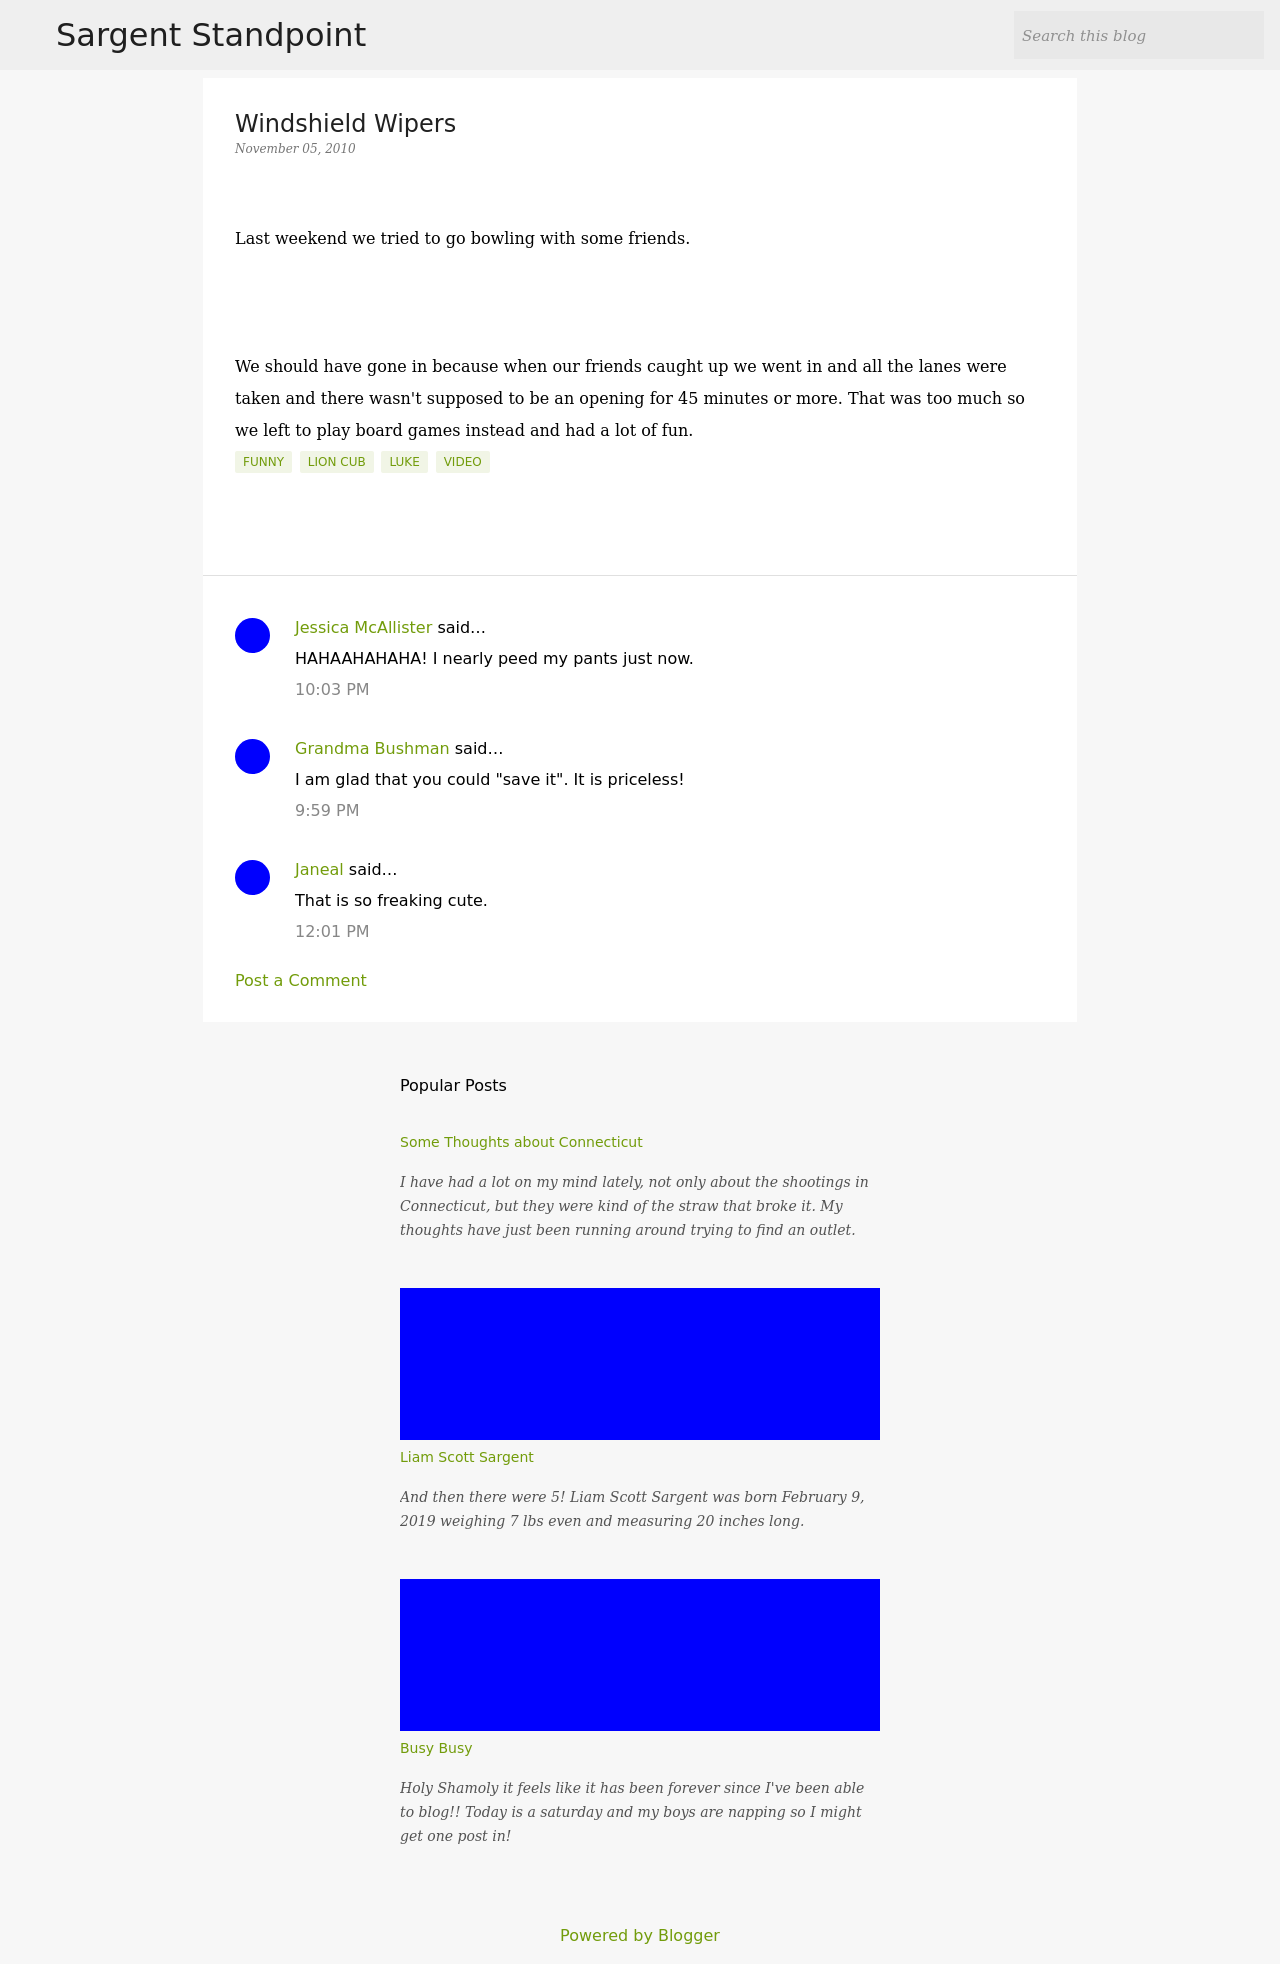What does the blog post discuss? The blog post titled 'Windshield Wipers' recounts a humorous experience where the author planned to go bowling with friends, but ended up playing board games instead due to a long waiting time for bowling lanes. 